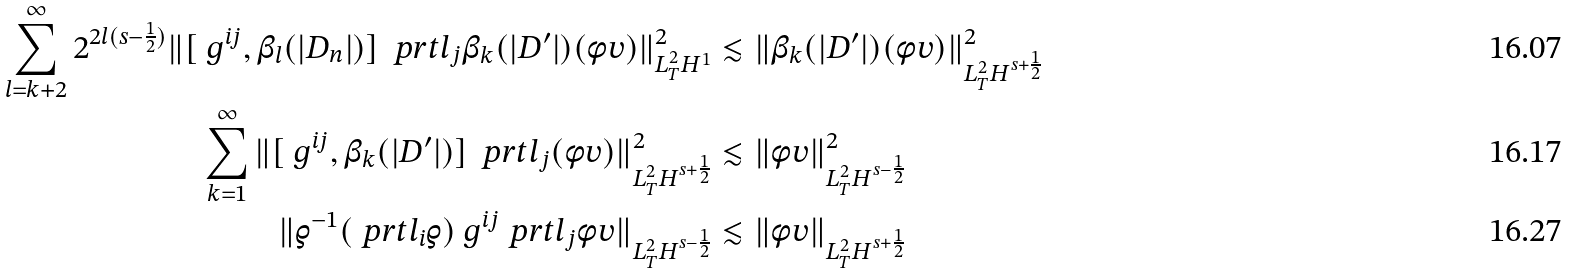<formula> <loc_0><loc_0><loc_500><loc_500>\sum _ { l = k + 2 } ^ { \infty } 2 ^ { 2 l ( s - \frac { 1 } { 2 } ) } \| [ \ g ^ { i j } , \beta _ { l } ( | D _ { n } | ) ] \, \ p r t l _ { j } \beta _ { k } ( | D ^ { \prime } | ) ( \phi v ) \| _ { L ^ { 2 } _ { T } H ^ { 1 } } ^ { 2 } & \lesssim \| \beta _ { k } ( | D ^ { \prime } | ) ( \phi v ) \| _ { L ^ { 2 } _ { T } H ^ { s + \frac { 1 } { 2 } } } ^ { 2 } \\ \sum _ { k = 1 } ^ { \infty } \| [ \ g ^ { i j } , \beta _ { k } ( | D ^ { \prime } | ) ] \, \ p r t l _ { j } ( \phi v ) \| _ { L ^ { 2 } _ { T } H ^ { s + \frac { 1 } { 2 } } } ^ { 2 } & \lesssim \| \phi v \| _ { L ^ { 2 } _ { T } H ^ { s - \frac { 1 } { 2 } } } ^ { 2 } \\ \| \varrho ^ { - 1 } ( \ p r t l _ { i } \varrho ) \ g ^ { i j } \ p r t l _ { j } \phi v \| _ { L ^ { 2 } _ { T } H ^ { s - \frac { 1 } { 2 } } } & \lesssim \| \phi v \| _ { L ^ { 2 } _ { T } H ^ { s + \frac { 1 } { 2 } } }</formula> 